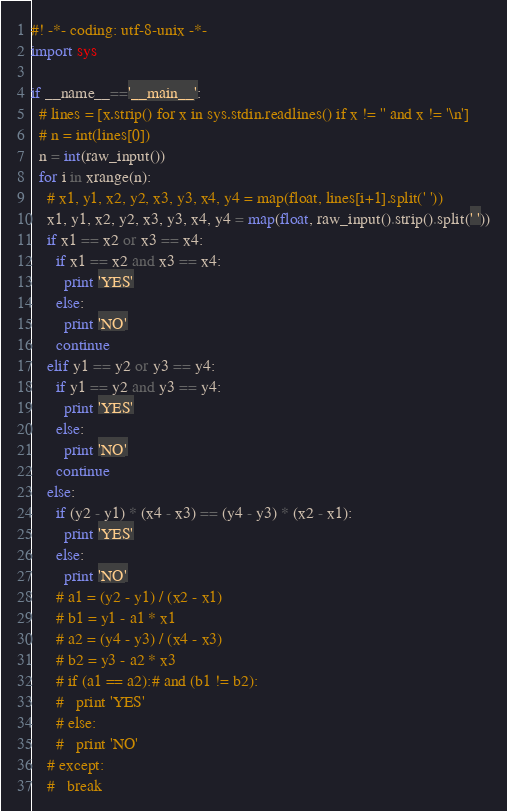<code> <loc_0><loc_0><loc_500><loc_500><_Python_>#! -*- coding: utf-8-unix -*-
import sys

if __name__=='__main__':
  # lines = [x.strip() for x in sys.stdin.readlines() if x != '' and x != '\n']
  # n = int(lines[0])
  n = int(raw_input())
  for i in xrange(n):
    # x1, y1, x2, y2, x3, y3, x4, y4 = map(float, lines[i+1].split(' '))
    x1, y1, x2, y2, x3, y3, x4, y4 = map(float, raw_input().strip().split(' '))
    if x1 == x2 or x3 == x4:
      if x1 == x2 and x3 == x4:
        print 'YES'
      else:
        print 'NO'
      continue
    elif y1 == y2 or y3 == y4:
      if y1 == y2 and y3 == y4:
        print 'YES'
      else:
        print 'NO'
      continue
    else:
      if (y2 - y1) * (x4 - x3) == (y4 - y3) * (x2 - x1):
        print 'YES'
      else:
        print 'NO'
      # a1 = (y2 - y1) / (x2 - x1)
      # b1 = y1 - a1 * x1
      # a2 = (y4 - y3) / (x4 - x3)
      # b2 = y3 - a2 * x3
      # if (a1 == a2):# and (b1 != b2):
      #   print 'YES'
      # else:
      #   print 'NO'
    # except:
    #   break</code> 